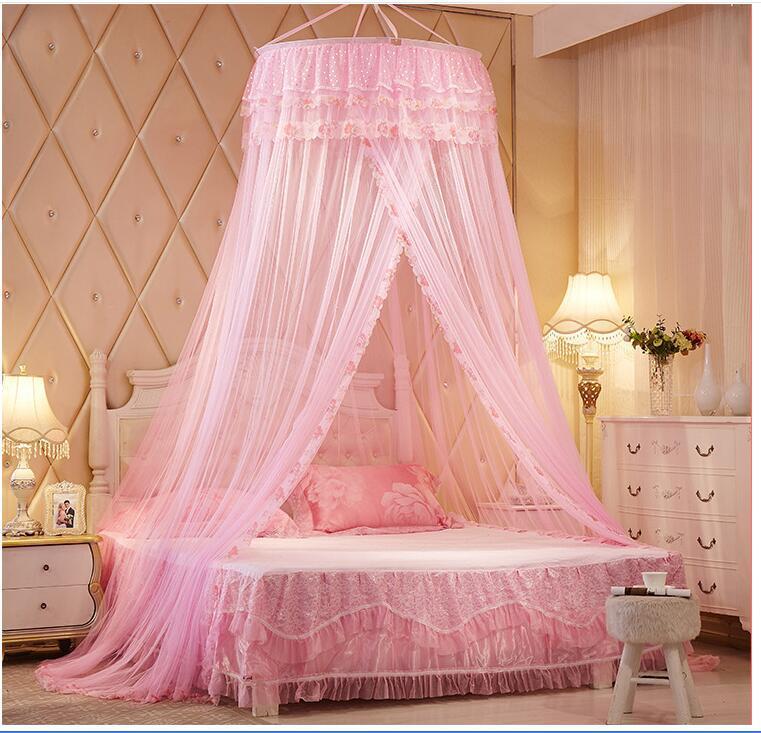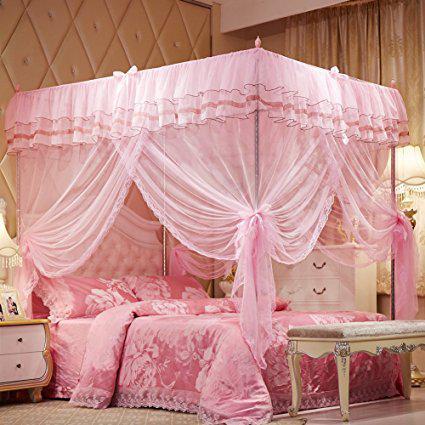The first image is the image on the left, the second image is the image on the right. Evaluate the accuracy of this statement regarding the images: "One of the beds has four posts.". Is it true? Answer yes or no. Yes. The first image is the image on the left, the second image is the image on the right. Given the left and right images, does the statement "The image on the left contains a pink circular net over a bed." hold true? Answer yes or no. Yes. 